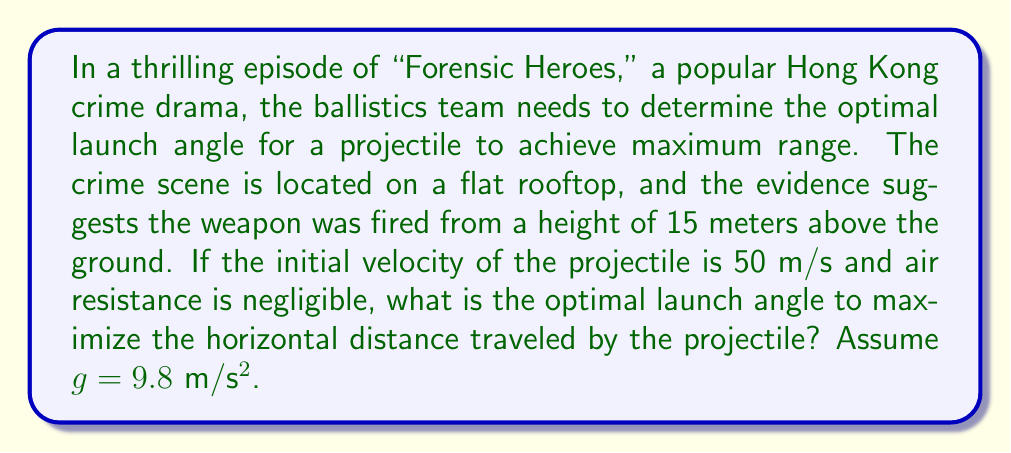Provide a solution to this math problem. To solve this problem, we'll use the principles of projectile motion and calculus to find the optimal launch angle. Let's break it down step by step:

1) The horizontal distance traveled by a projectile launched from a height h with initial velocity v and angle θ is given by:

   $$R = v \cos(\theta) \left(\frac{v \sin(\theta) + \sqrt{(v \sin(\theta))^2 + 2gh}}{g}\right)$$

2) Our goal is to maximize R with respect to θ. To do this, we need to find the derivative of R with respect to θ and set it equal to zero:

   $$\frac{dR}{d\theta} = 0$$

3) Taking the derivative is complex, but it can be shown that the optimal angle is given by:

   $$\theta_{opt} = \arctan\left(\sqrt{\frac{1 + \sqrt{1 + \frac{2gh}{v^2}}}{1 + \frac{2gh}{v^2}}}\right)$$

4) Now, let's substitute our values:
   h = 15 m
   v = 50 m/s
   g = 9.8 m/s²

5) First, calculate $\frac{2gh}{v^2}$:

   $$\frac{2gh}{v^2} = \frac{2 \cdot 9.8 \cdot 15}{50^2} = 0.1176$$

6) Now, let's substitute this into our optimal angle formula:

   $$\theta_{opt} = \arctan\left(\sqrt{\frac{1 + \sqrt{1 + 0.1176}}{1 + 0.1176}}\right)$$

7) Simplifying:

   $$\theta_{opt} = \arctan\left(\sqrt{\frac{1 + 1.0574}{1.1176}}\right) = \arctan\left(\sqrt{\frac{2.0574}{1.1176}}\right)$$

8) Calculating:

   $$\theta_{opt} = \arctan(\sqrt{1.8409}) = \arctan(1.3568) \approx 0.9358 \text{ radians}$$

9) Converting to degrees:

   $$\theta_{opt} \approx 53.62°$$
Answer: The optimal launch angle to maximize the horizontal distance traveled by the projectile is approximately 53.62°. 